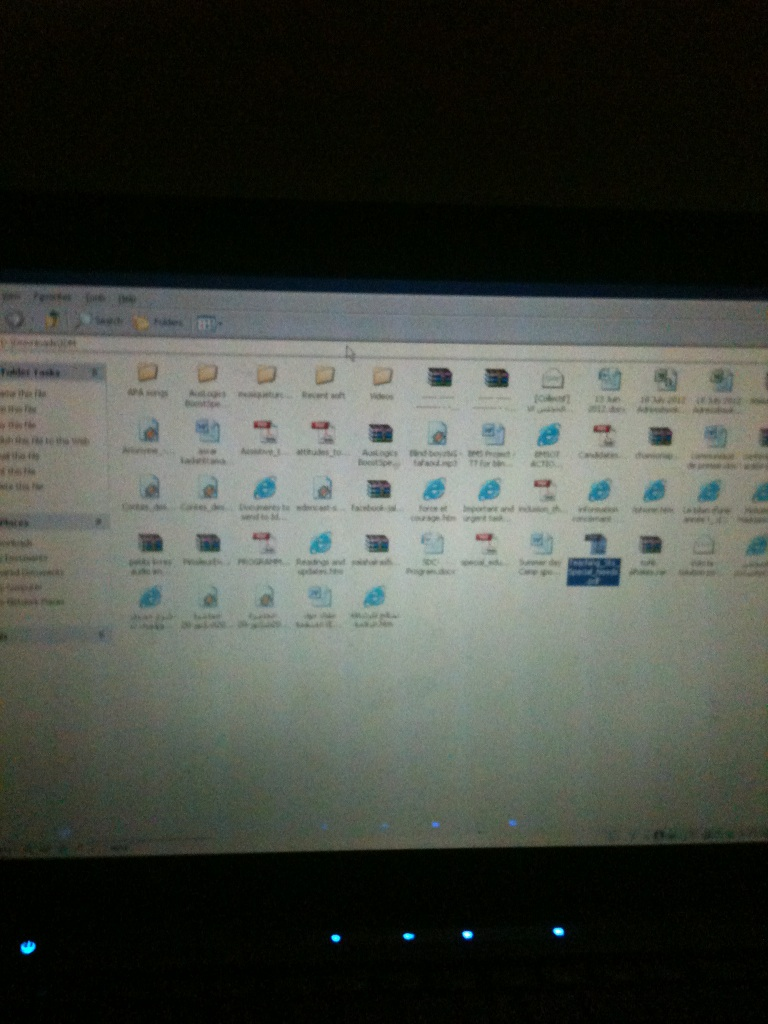Can you describe the different types of files or icons present in this folder? This folder contains a variety of file types and icons. There are program shortcuts, document files, and what appear to be Internet Explorer or Edge browser icons. The names suggest files related to academic works, software installs, and personal documents. Specific icons, like the Internet Explorer logos, indicate web-related shortcuts or files saved from browsing. Is there any indication of the purpose of this folder? Based on the file names, this folder could be a general-use or a miscellaneous folder where the user stores various types of files they frequently access. It might also be grouped from a backup or organized based on necessity. 